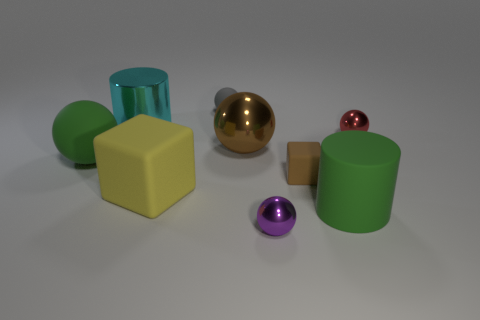Does the large cylinder in front of the tiny brown block have the same color as the large matte ball? yes 